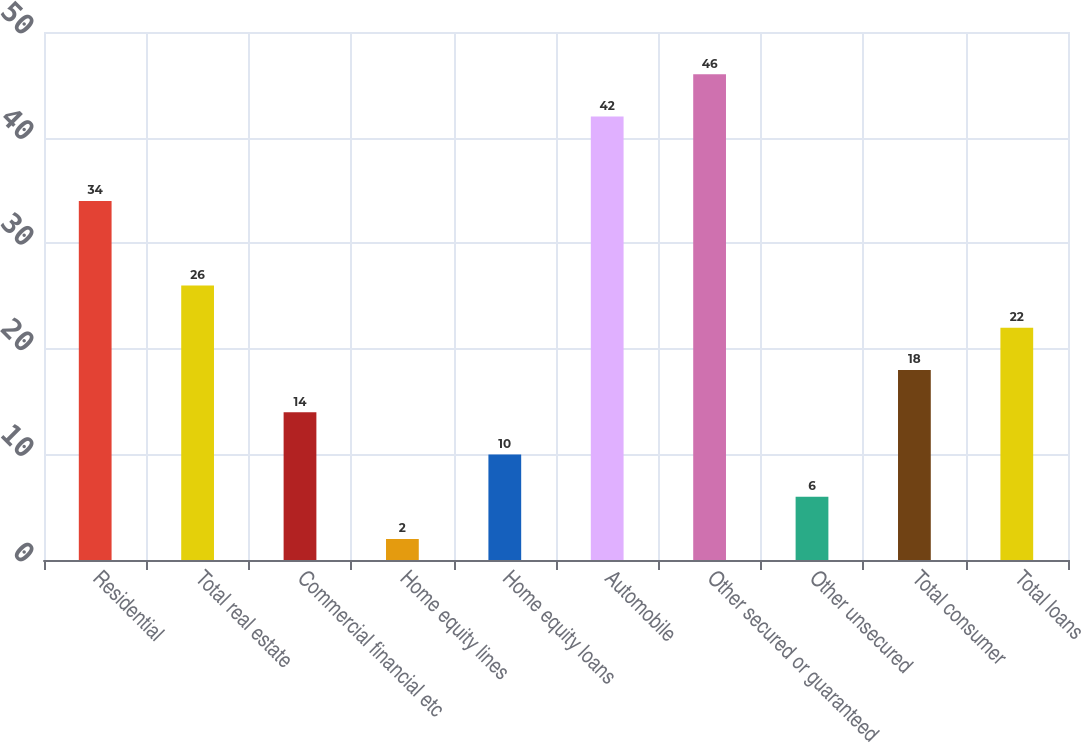Convert chart to OTSL. <chart><loc_0><loc_0><loc_500><loc_500><bar_chart><fcel>Residential<fcel>Total real estate<fcel>Commercial financial etc<fcel>Home equity lines<fcel>Home equity loans<fcel>Automobile<fcel>Other secured or guaranteed<fcel>Other unsecured<fcel>Total consumer<fcel>Total loans<nl><fcel>34<fcel>26<fcel>14<fcel>2<fcel>10<fcel>42<fcel>46<fcel>6<fcel>18<fcel>22<nl></chart> 